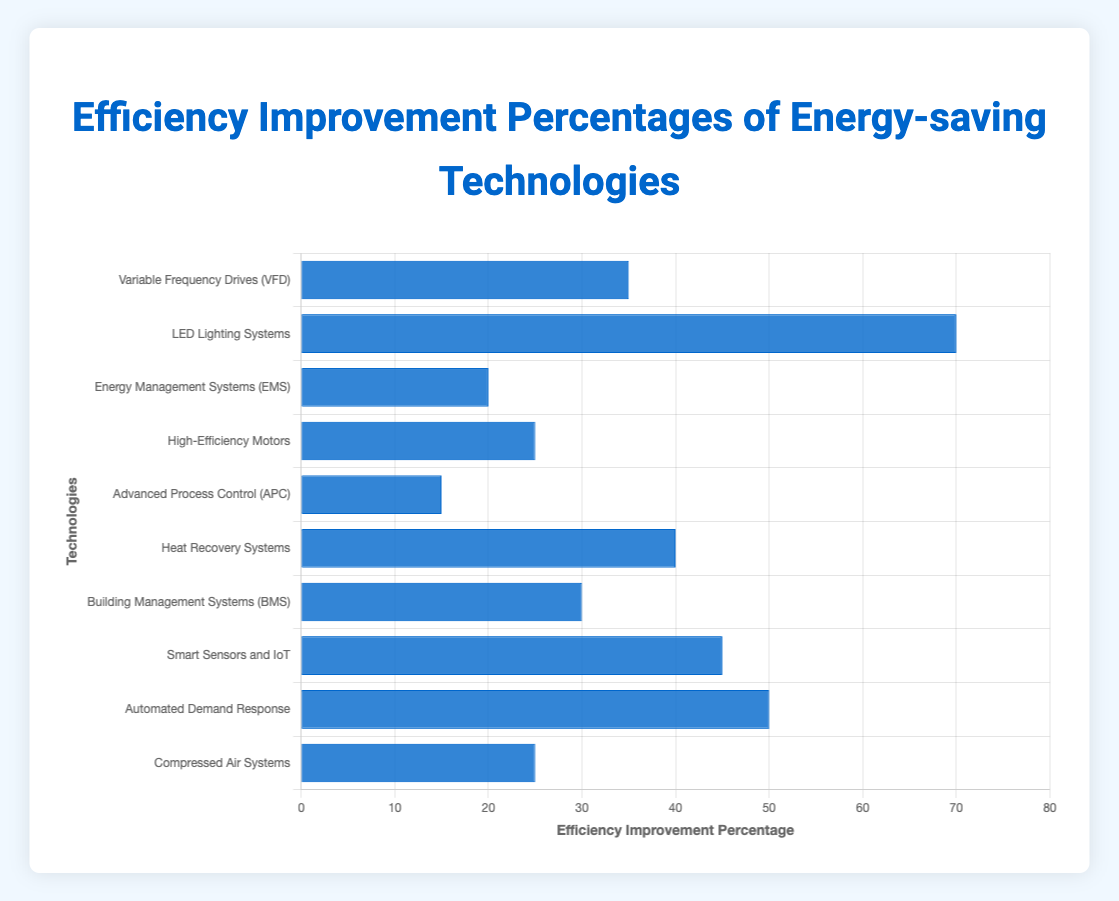How much more efficient are LED Lighting Systems compared to Advanced Process Control (APC)? LED Lighting Systems have an efficiency improvement percentage of 70%, while Advanced Process Control (APC) has 15%. The difference in efficiency improvement is calculated as 70% - 15% = 55%.
Answer: 55% Which technology has the highest efficiency improvement percentage? By inspecting the lengths of the blue bars, we observe that the LED Lighting Systems bar is the longest at 70%, indicating it has the highest efficiency improvement percentage among the listed technologies.
Answer: LED Lighting Systems What's the combined efficiency improvement percentage of High-Efficiency Motors and Compressed Air Systems? High-Efficiency Motors have an efficiency improvement percentage of 25% and Compressed Air Systems also have 25%. Adding these percentages gives 25% + 25% = 50%.
Answer: 50% Which technology is more efficient: Smart Sensors and IoT or Automated Demand Response? Comparing the bar lengths, Smart Sensors and IoT have an efficiency improvement percentage of 45% while Automated Demand Response shows 50%. Thus, Automated Demand Response is more efficient.
Answer: Automated Demand Response What is the average efficiency improvement percentage of Heat Recovery Systems, Building Management Systems (BMS), and Smart Sensors and IoT? The efficiency improvement percentages are 40% for Heat Recovery Systems, 30% for Building Management Systems (BMS), and 45% for Smart Sensors and IoT. The average is calculated as (40% + 30% + 45%) / 3 = 115% / 3 ≈ 38.33%.
Answer: 38.33% What's the smallest efficiency improvement percentage amongst all the technologies? By inspecting all the bar lengths, Advanced Process Control (APC) has the smallest efficiency improvement percentage at 15%.
Answer: Advanced Process Control Is the efficiency improvement percentage of Building Management Systems (BMS) closer to Variable Frequency Drives (VFD) or High-Efficiency Motors? Building Management Systems (BMS) have an efficiency improvement percentage of 30%. Variable Frequency Drives (VFD) have 35%, and High-Efficiency Motors have 25%. The difference is
Answer: Variable Frequency Drives (VFD) What is the difference in efficiency improvement percentage between the least and most efficient technology? The least efficient technology is Advanced Process Control (APC) at 15%, and the most efficient is LED Lighting Systems at 70%. The difference is 70% - 15% = 55%.
Answer: 55% Does any technology have exactly double the efficiency improvement percentage of another technology? By comparing the percentages, Automated Demand Response at 50% is exactly double that of Energy Management Systems (EMS) at 25%.
Answer: Yes Which technologies have an efficiency improvement percentage greater than 40%? The technologies with efficiency improvement percentages greater than 40% are Heat Recovery Systems (40%), Smart Sensors and IoT (45%), Automated Demand Response (50%), and LED Lighting Systems (70%). Excluding Heat Recovery Systems since it is exactly 40%.
Answer: Smart Sensors and IoT, Automated Demand Response, LED Lighting Systems 